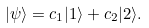Convert formula to latex. <formula><loc_0><loc_0><loc_500><loc_500>| \psi \rangle = c _ { 1 } | 1 \rangle + c _ { 2 } | 2 \rangle .</formula> 